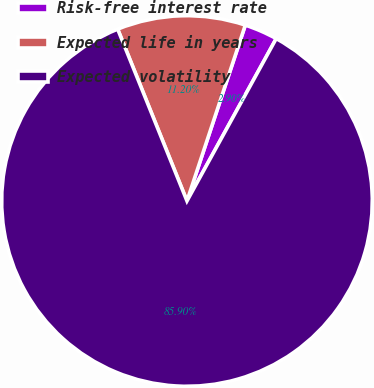<chart> <loc_0><loc_0><loc_500><loc_500><pie_chart><fcel>Risk-free interest rate<fcel>Expected life in years<fcel>Expected volatility<nl><fcel>2.9%<fcel>11.2%<fcel>85.9%<nl></chart> 